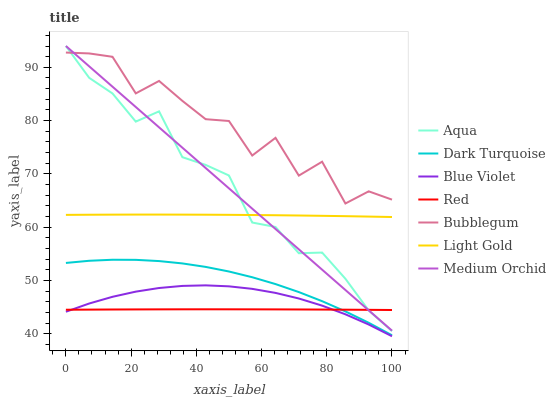Does Red have the minimum area under the curve?
Answer yes or no. Yes. Does Bubblegum have the maximum area under the curve?
Answer yes or no. Yes. Does Medium Orchid have the minimum area under the curve?
Answer yes or no. No. Does Medium Orchid have the maximum area under the curve?
Answer yes or no. No. Is Medium Orchid the smoothest?
Answer yes or no. Yes. Is Bubblegum the roughest?
Answer yes or no. Yes. Is Aqua the smoothest?
Answer yes or no. No. Is Aqua the roughest?
Answer yes or no. No. Does Blue Violet have the lowest value?
Answer yes or no. Yes. Does Medium Orchid have the lowest value?
Answer yes or no. No. Does Aqua have the highest value?
Answer yes or no. Yes. Does Bubblegum have the highest value?
Answer yes or no. No. Is Blue Violet less than Dark Turquoise?
Answer yes or no. Yes. Is Light Gold greater than Red?
Answer yes or no. Yes. Does Red intersect Medium Orchid?
Answer yes or no. Yes. Is Red less than Medium Orchid?
Answer yes or no. No. Is Red greater than Medium Orchid?
Answer yes or no. No. Does Blue Violet intersect Dark Turquoise?
Answer yes or no. No. 